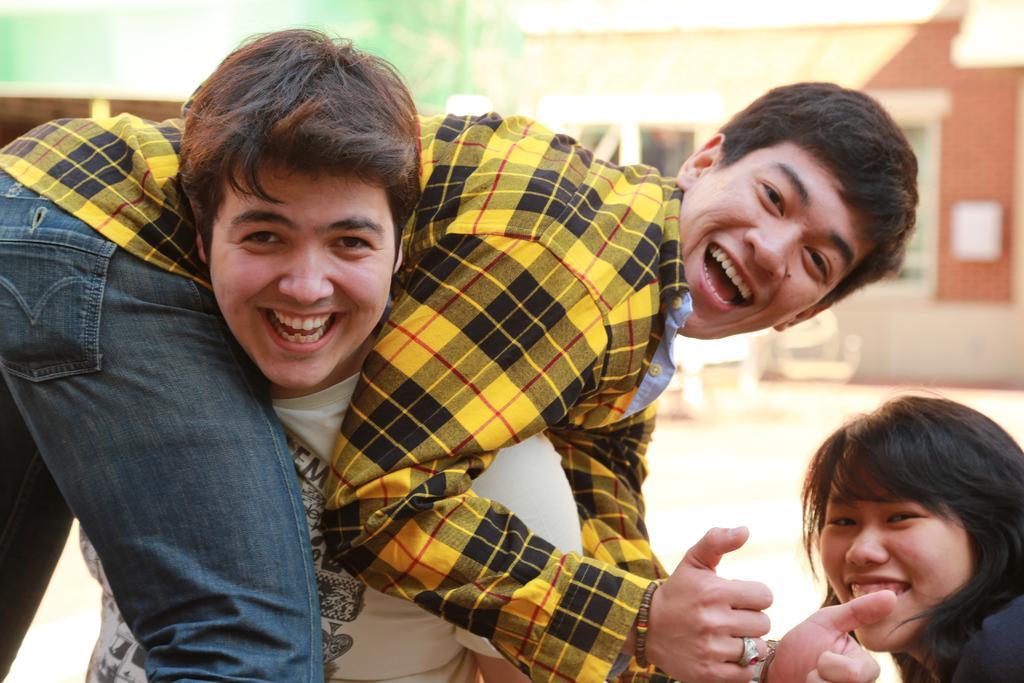How would you summarize this image in a sentence or two? In this picture we can see three persons. Behind the three persons, there is a blurred background. 